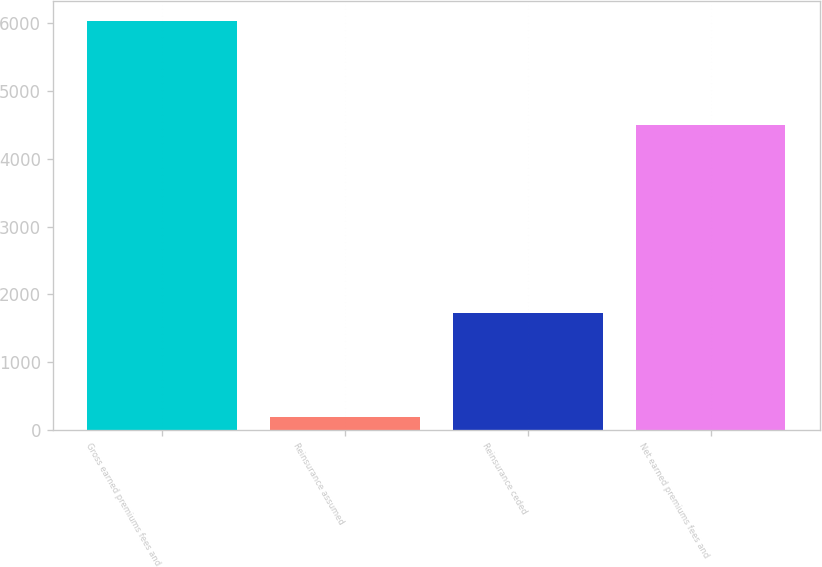<chart> <loc_0><loc_0><loc_500><loc_500><bar_chart><fcel>Gross earned premiums fees and<fcel>Reinsurance assumed<fcel>Reinsurance ceded<fcel>Net earned premiums fees and<nl><fcel>6029<fcel>193<fcel>1720<fcel>4502<nl></chart> 